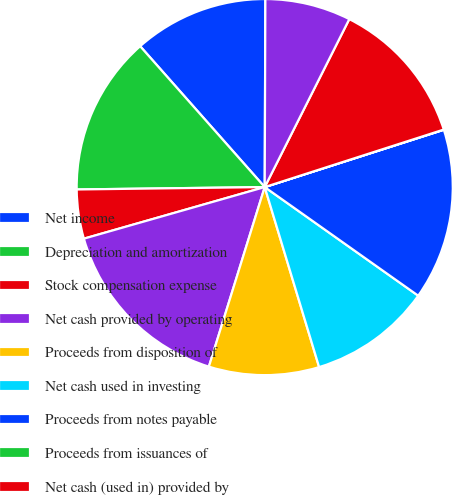<chart> <loc_0><loc_0><loc_500><loc_500><pie_chart><fcel>Net income<fcel>Depreciation and amortization<fcel>Stock compensation expense<fcel>Net cash provided by operating<fcel>Proceeds from disposition of<fcel>Net cash used in investing<fcel>Proceeds from notes payable<fcel>Proceeds from issuances of<fcel>Net cash (used in) provided by<fcel>Cash and cash equivalents<nl><fcel>11.58%<fcel>13.68%<fcel>4.22%<fcel>15.78%<fcel>9.47%<fcel>10.53%<fcel>14.73%<fcel>0.02%<fcel>12.63%<fcel>7.37%<nl></chart> 